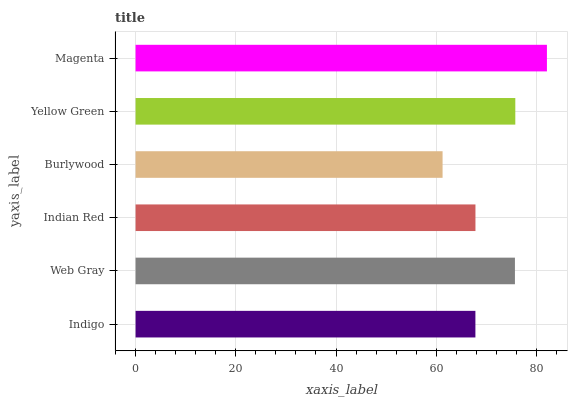Is Burlywood the minimum?
Answer yes or no. Yes. Is Magenta the maximum?
Answer yes or no. Yes. Is Web Gray the minimum?
Answer yes or no. No. Is Web Gray the maximum?
Answer yes or no. No. Is Web Gray greater than Indigo?
Answer yes or no. Yes. Is Indigo less than Web Gray?
Answer yes or no. Yes. Is Indigo greater than Web Gray?
Answer yes or no. No. Is Web Gray less than Indigo?
Answer yes or no. No. Is Web Gray the high median?
Answer yes or no. Yes. Is Indian Red the low median?
Answer yes or no. Yes. Is Burlywood the high median?
Answer yes or no. No. Is Magenta the low median?
Answer yes or no. No. 